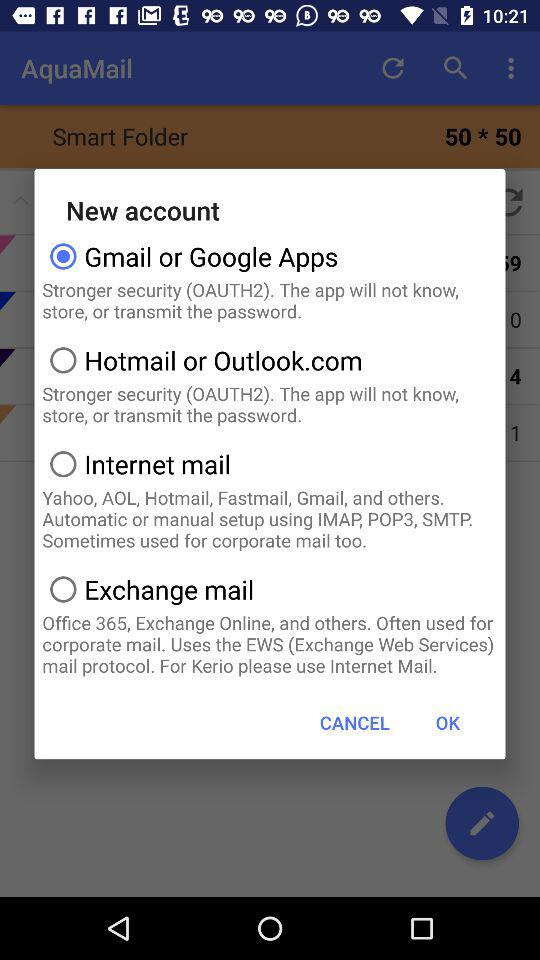What is the user's name?
When the provided information is insufficient, respond with <no answer>. <no answer> 